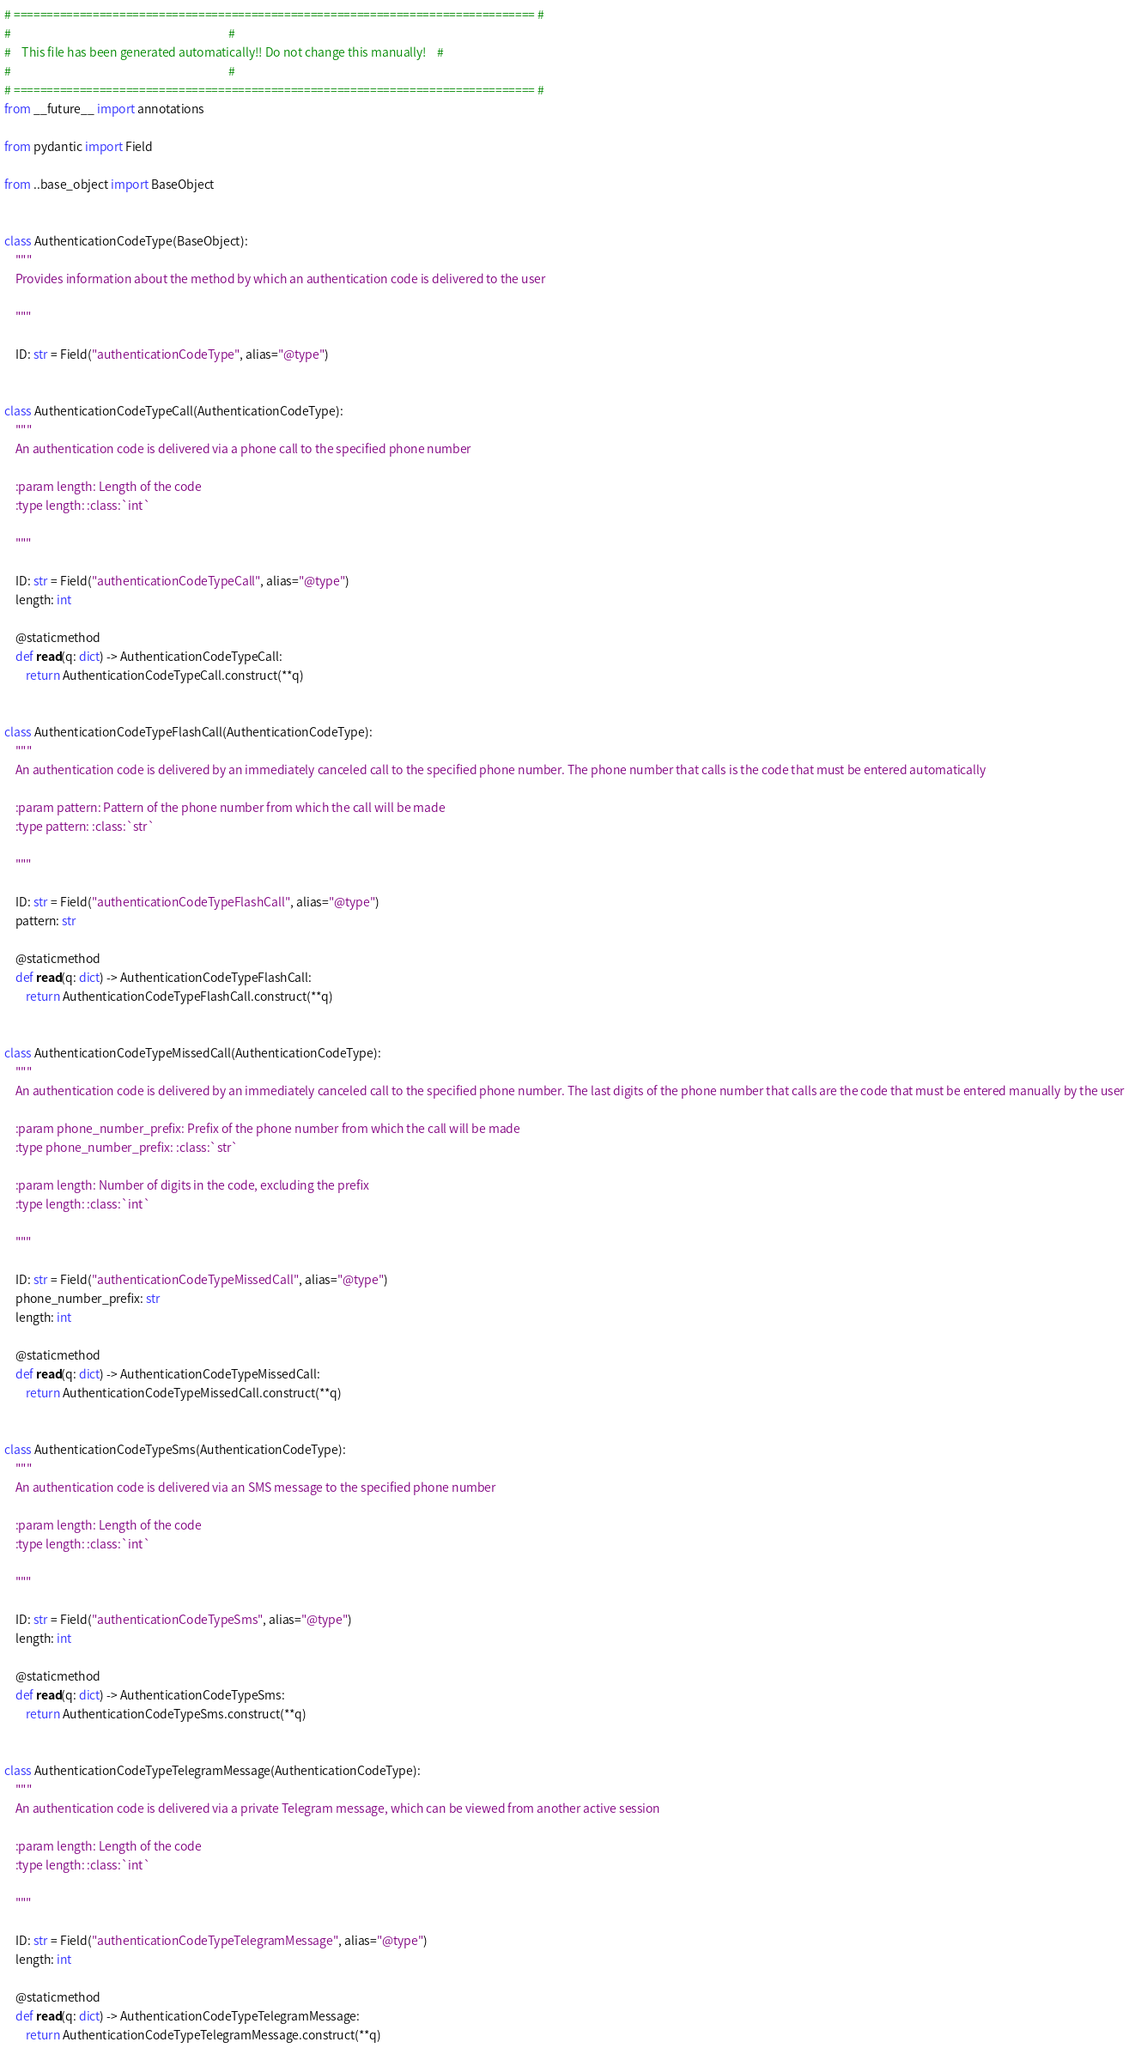<code> <loc_0><loc_0><loc_500><loc_500><_Python_># =============================================================================== #
#                                                                                 #
#    This file has been generated automatically!! Do not change this manually!    #
#                                                                                 #
# =============================================================================== #
from __future__ import annotations

from pydantic import Field

from ..base_object import BaseObject


class AuthenticationCodeType(BaseObject):
    """
    Provides information about the method by which an authentication code is delivered to the user
    
    """

    ID: str = Field("authenticationCodeType", alias="@type")


class AuthenticationCodeTypeCall(AuthenticationCodeType):
    """
    An authentication code is delivered via a phone call to the specified phone number
    
    :param length: Length of the code
    :type length: :class:`int`
    
    """

    ID: str = Field("authenticationCodeTypeCall", alias="@type")
    length: int

    @staticmethod
    def read(q: dict) -> AuthenticationCodeTypeCall:
        return AuthenticationCodeTypeCall.construct(**q)


class AuthenticationCodeTypeFlashCall(AuthenticationCodeType):
    """
    An authentication code is delivered by an immediately canceled call to the specified phone number. The phone number that calls is the code that must be entered automatically
    
    :param pattern: Pattern of the phone number from which the call will be made
    :type pattern: :class:`str`
    
    """

    ID: str = Field("authenticationCodeTypeFlashCall", alias="@type")
    pattern: str

    @staticmethod
    def read(q: dict) -> AuthenticationCodeTypeFlashCall:
        return AuthenticationCodeTypeFlashCall.construct(**q)


class AuthenticationCodeTypeMissedCall(AuthenticationCodeType):
    """
    An authentication code is delivered by an immediately canceled call to the specified phone number. The last digits of the phone number that calls are the code that must be entered manually by the user
    
    :param phone_number_prefix: Prefix of the phone number from which the call will be made
    :type phone_number_prefix: :class:`str`
    
    :param length: Number of digits in the code, excluding the prefix
    :type length: :class:`int`
    
    """

    ID: str = Field("authenticationCodeTypeMissedCall", alias="@type")
    phone_number_prefix: str
    length: int

    @staticmethod
    def read(q: dict) -> AuthenticationCodeTypeMissedCall:
        return AuthenticationCodeTypeMissedCall.construct(**q)


class AuthenticationCodeTypeSms(AuthenticationCodeType):
    """
    An authentication code is delivered via an SMS message to the specified phone number
    
    :param length: Length of the code
    :type length: :class:`int`
    
    """

    ID: str = Field("authenticationCodeTypeSms", alias="@type")
    length: int

    @staticmethod
    def read(q: dict) -> AuthenticationCodeTypeSms:
        return AuthenticationCodeTypeSms.construct(**q)


class AuthenticationCodeTypeTelegramMessage(AuthenticationCodeType):
    """
    An authentication code is delivered via a private Telegram message, which can be viewed from another active session
    
    :param length: Length of the code
    :type length: :class:`int`
    
    """

    ID: str = Field("authenticationCodeTypeTelegramMessage", alias="@type")
    length: int

    @staticmethod
    def read(q: dict) -> AuthenticationCodeTypeTelegramMessage:
        return AuthenticationCodeTypeTelegramMessage.construct(**q)
</code> 